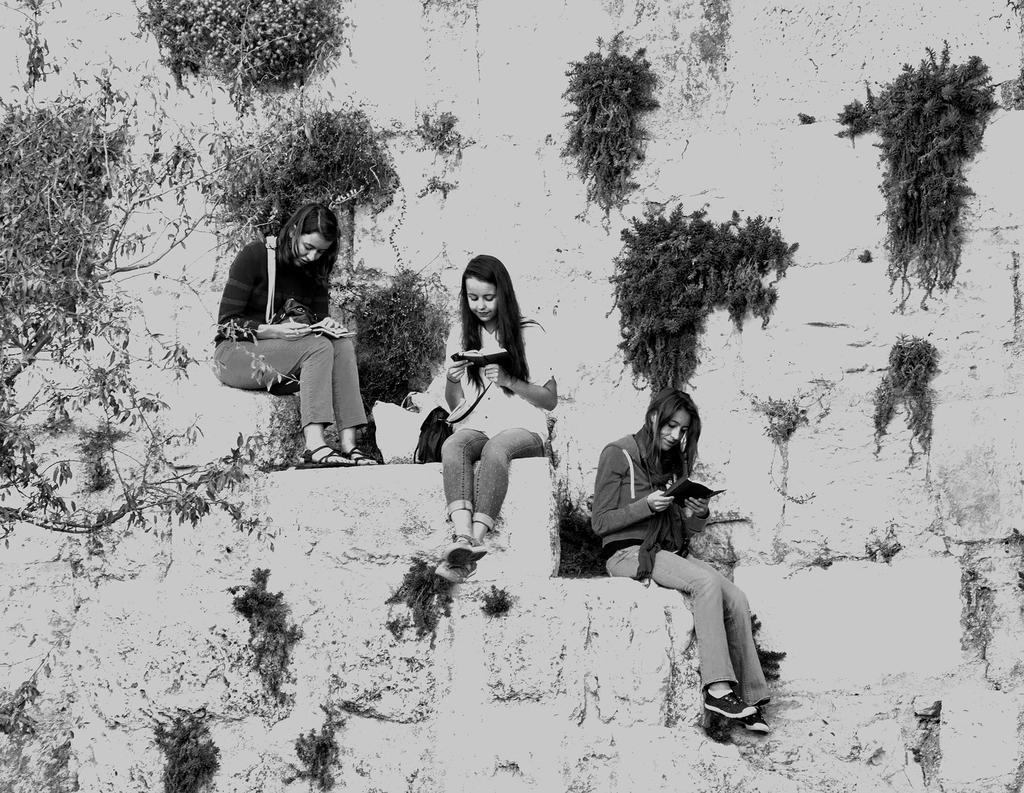Could you give a brief overview of what you see in this image? In this image I can see it is a black and white image, three girls are sitting on the stairs and reading the books. There are plants on this wall. 